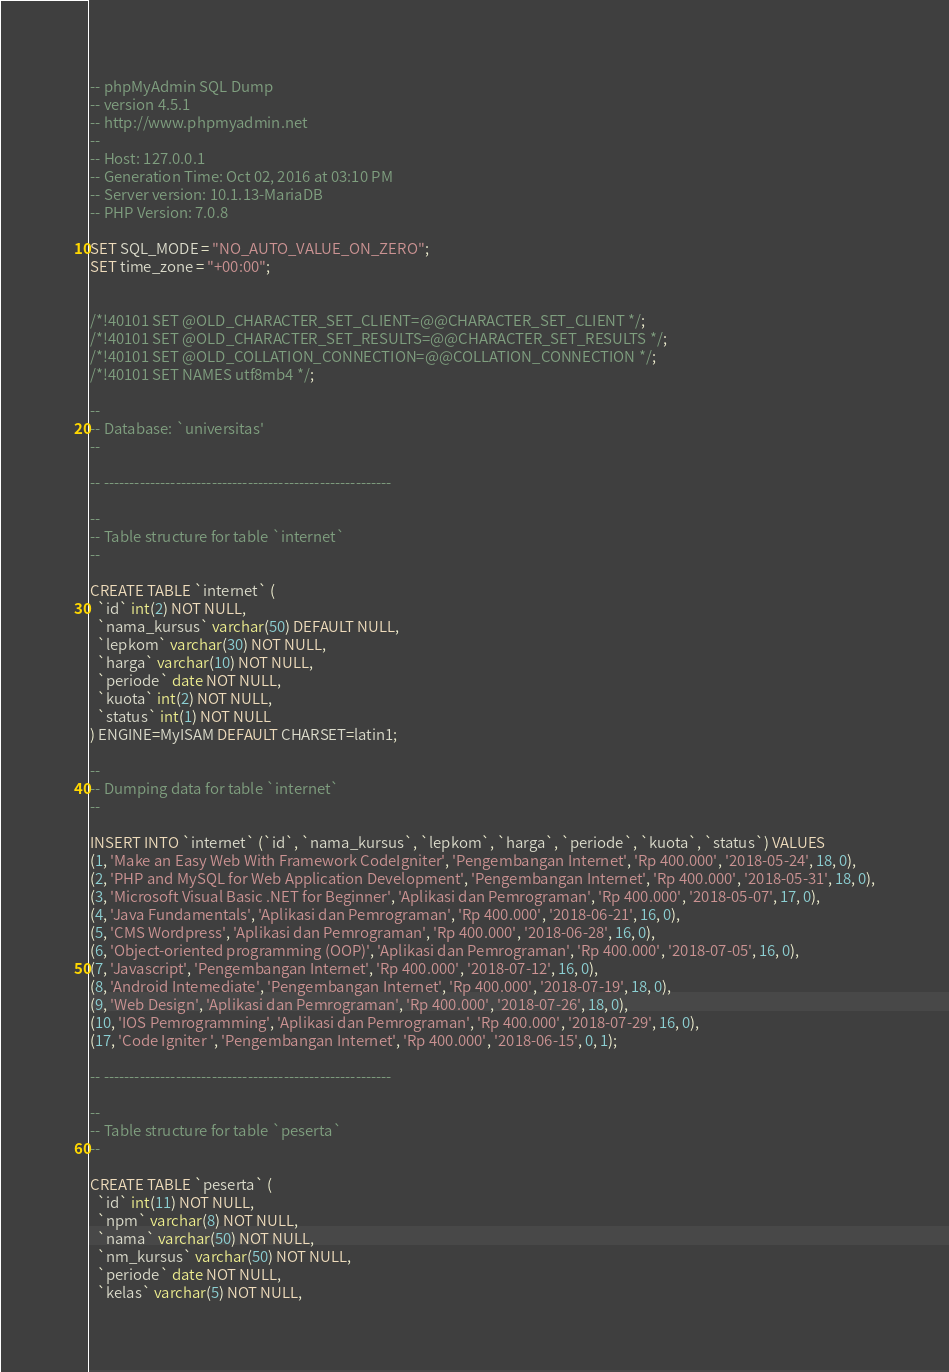<code> <loc_0><loc_0><loc_500><loc_500><_SQL_>-- phpMyAdmin SQL Dump
-- version 4.5.1
-- http://www.phpmyadmin.net
--
-- Host: 127.0.0.1
-- Generation Time: Oct 02, 2016 at 03:10 PM
-- Server version: 10.1.13-MariaDB
-- PHP Version: 7.0.8

SET SQL_MODE = "NO_AUTO_VALUE_ON_ZERO";
SET time_zone = "+00:00";


/*!40101 SET @OLD_CHARACTER_SET_CLIENT=@@CHARACTER_SET_CLIENT */;
/*!40101 SET @OLD_CHARACTER_SET_RESULTS=@@CHARACTER_SET_RESULTS */;
/*!40101 SET @OLD_COLLATION_CONNECTION=@@COLLATION_CONNECTION */;
/*!40101 SET NAMES utf8mb4 */;

--
-- Database: `universitas'
--

-- --------------------------------------------------------

--
-- Table structure for table `internet`
--

CREATE TABLE `internet` (
  `id` int(2) NOT NULL,
  `nama_kursus` varchar(50) DEFAULT NULL,
  `lepkom` varchar(30) NOT NULL,
  `harga` varchar(10) NOT NULL,
  `periode` date NOT NULL,
  `kuota` int(2) NOT NULL,
  `status` int(1) NOT NULL
) ENGINE=MyISAM DEFAULT CHARSET=latin1;

--
-- Dumping data for table `internet`
--

INSERT INTO `internet` (`id`, `nama_kursus`, `lepkom`, `harga`, `periode`, `kuota`, `status`) VALUES
(1, 'Make an Easy Web With Framework CodeIgniter', 'Pengembangan Internet', 'Rp 400.000', '2018-05-24', 18, 0),
(2, 'PHP and MySQL for Web Application Development', 'Pengembangan Internet', 'Rp 400.000', '2018-05-31', 18, 0),
(3, 'Microsoft Visual Basic .NET for Beginner', 'Aplikasi dan Pemrograman', 'Rp 400.000', '2018-05-07', 17, 0),
(4, 'Java Fundamentals', 'Aplikasi dan Pemrograman', 'Rp 400.000', '2018-06-21', 16, 0),
(5, 'CMS Wordpress', 'Aplikasi dan Pemrograman', 'Rp 400.000', '2018-06-28', 16, 0),
(6, 'Object-oriented programming (OOP)', 'Aplikasi dan Pemrograman', 'Rp 400.000', '2018-07-05', 16, 0),
(7, 'Javascript', 'Pengembangan Internet', 'Rp 400.000', '2018-07-12', 16, 0),
(8, 'Android Intemediate', 'Pengembangan Internet', 'Rp 400.000', '2018-07-19', 18, 0),
(9, 'Web Design', 'Aplikasi dan Pemrograman', 'Rp 400.000', '2018-07-26', 18, 0),
(10, 'IOS Pemrogramming', 'Aplikasi dan Pemrograman', 'Rp 400.000', '2018-07-29', 16, 0),
(17, 'Code Igniter ', 'Pengembangan Internet', 'Rp 400.000', '2018-06-15', 0, 1);

-- --------------------------------------------------------

--
-- Table structure for table `peserta`
--

CREATE TABLE `peserta` (
  `id` int(11) NOT NULL,
  `npm` varchar(8) NOT NULL,
  `nama` varchar(50) NOT NULL,
  `nm_kursus` varchar(50) NOT NULL,
  `periode` date NOT NULL,
  `kelas` varchar(5) NOT NULL,</code> 